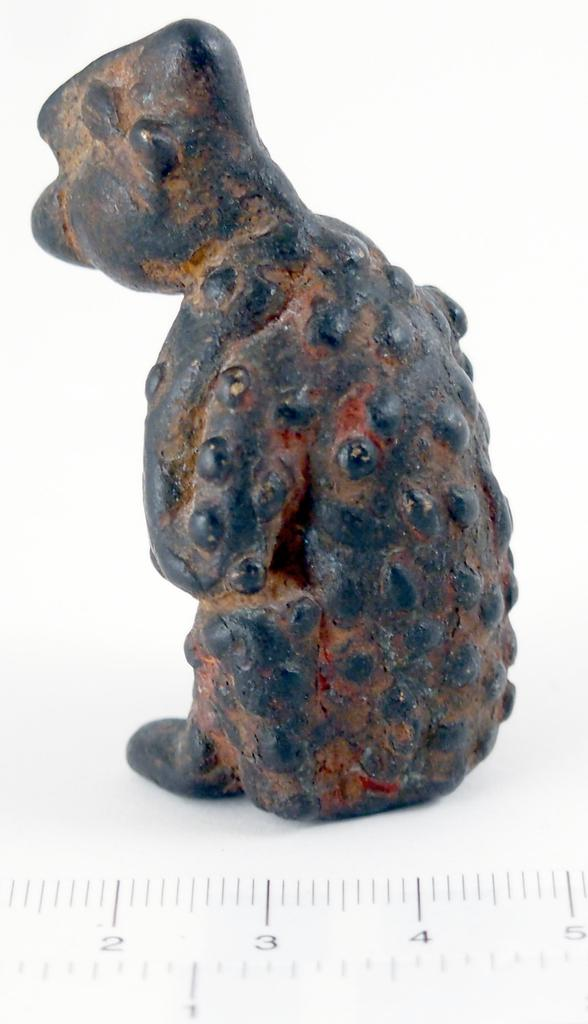What is the main object in the image? There is a scale in the image. Can you describe the object that is black and brown in color? The black and brown colored object in the image is not specified, but it is present alongside the scale. What color is the background of the image? The background of the image is white. What type of humor can be seen in the image? There is no humor present in the image, as it features a scale and a black and brown colored object against a white background. 